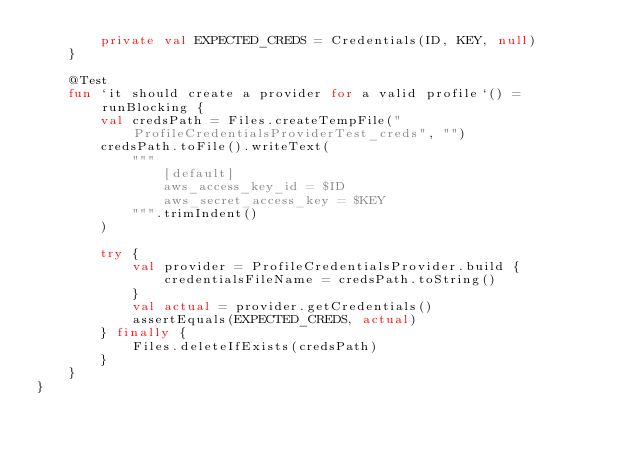Convert code to text. <code><loc_0><loc_0><loc_500><loc_500><_Kotlin_>        private val EXPECTED_CREDS = Credentials(ID, KEY, null)
    }

    @Test
    fun `it should create a provider for a valid profile`() = runBlocking {
        val credsPath = Files.createTempFile("ProfileCredentialsProviderTest_creds", "")
        credsPath.toFile().writeText(
            """
                [default]
                aws_access_key_id = $ID
                aws_secret_access_key = $KEY
            """.trimIndent()
        )

        try {
            val provider = ProfileCredentialsProvider.build {
                credentialsFileName = credsPath.toString()
            }
            val actual = provider.getCredentials()
            assertEquals(EXPECTED_CREDS, actual)
        } finally {
            Files.deleteIfExists(credsPath)
        }
    }
}
</code> 